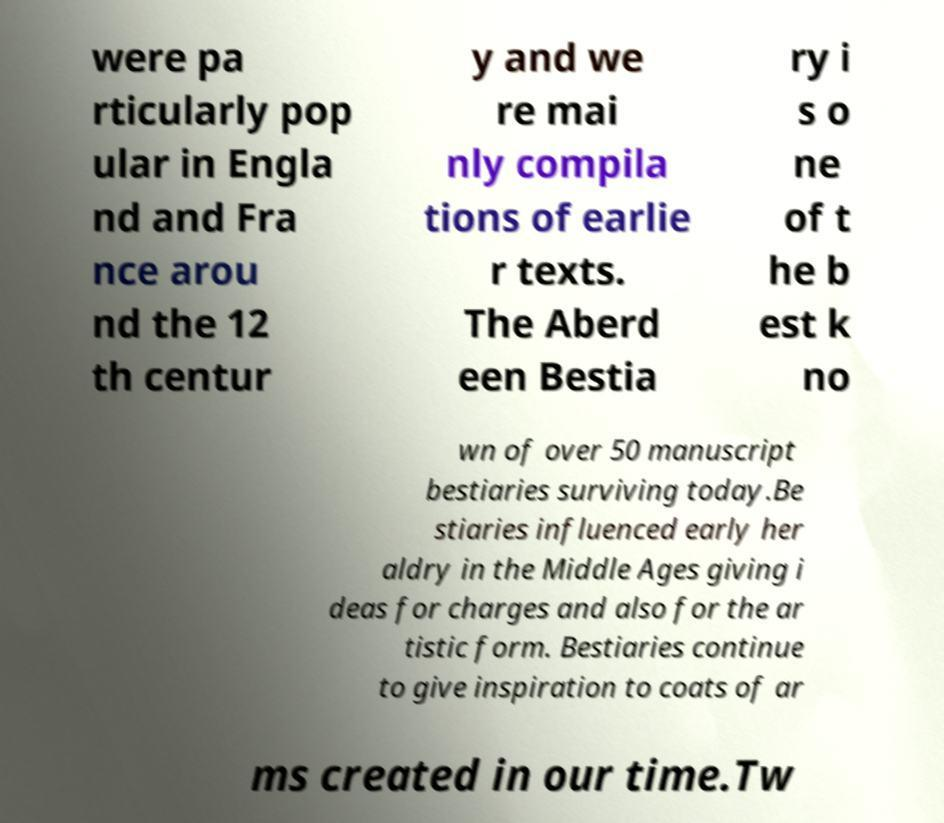Please read and relay the text visible in this image. What does it say? were pa rticularly pop ular in Engla nd and Fra nce arou nd the 12 th centur y and we re mai nly compila tions of earlie r texts. The Aberd een Bestia ry i s o ne of t he b est k no wn of over 50 manuscript bestiaries surviving today.Be stiaries influenced early her aldry in the Middle Ages giving i deas for charges and also for the ar tistic form. Bestiaries continue to give inspiration to coats of ar ms created in our time.Tw 